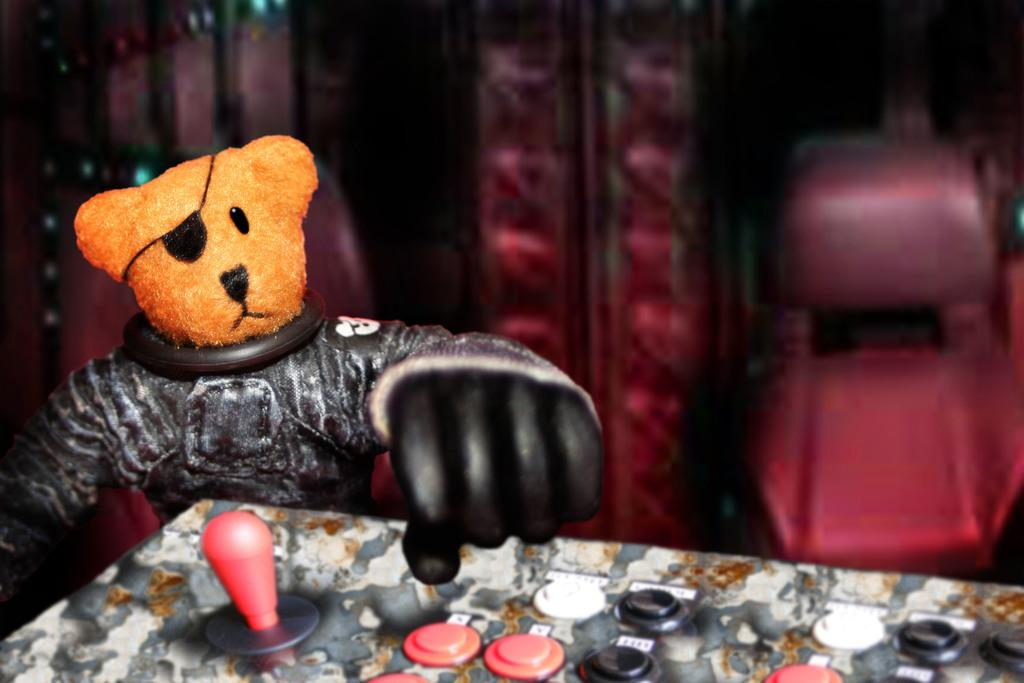What is on the left side of the image? There is a brown color teddy bear head on the left side of the image. What can be seen in the right side background of the image? There is a red color chair in the right side background of the image. What type of umbrella is being used by the teddy bear in the image? There is no umbrella present in the image; it only features a teddy bear head and a red chair. How many roots can be seen growing from the teddy bear in the image? There are no roots present in the image; it only features a teddy bear head and a red chair. 